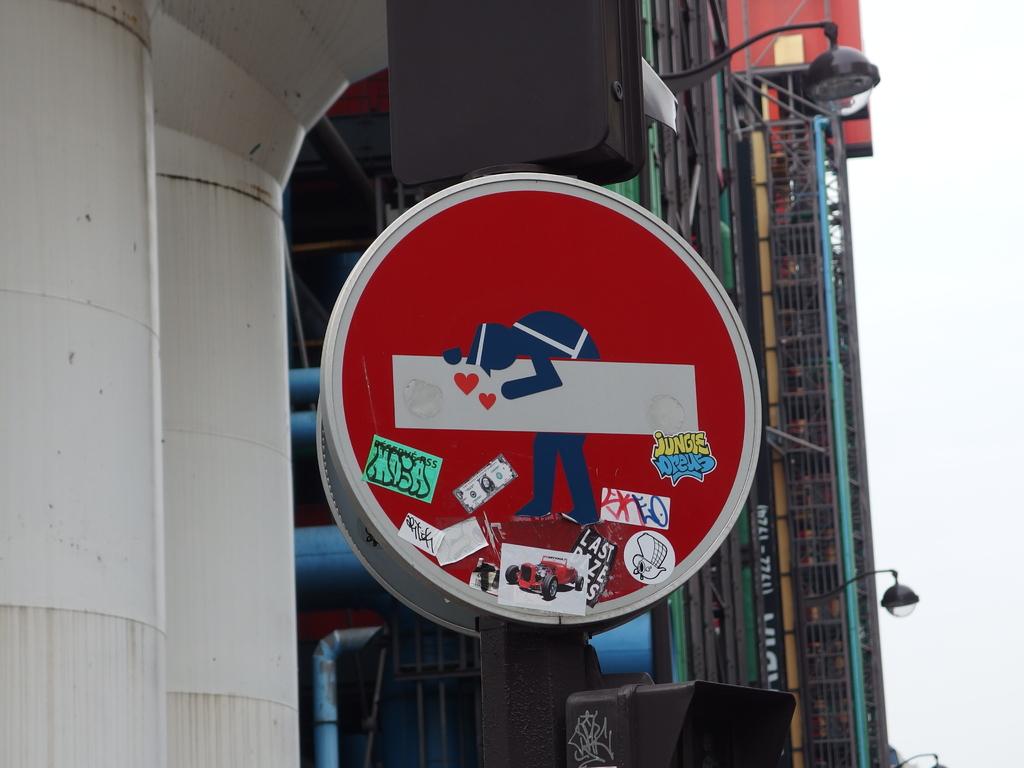What does the yellow & blue sticker say?
Ensure brevity in your answer.  Jungle breus. 